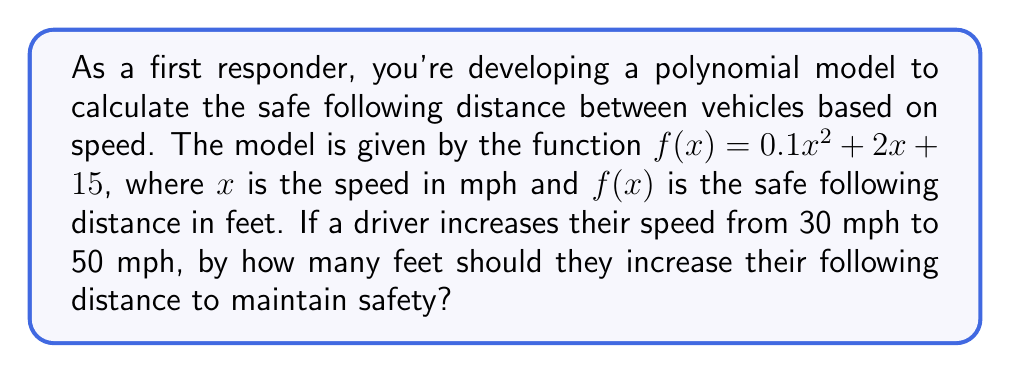Provide a solution to this math problem. To solve this problem, we need to follow these steps:

1) Calculate the safe following distance at 30 mph:
   $f(30) = 0.1(30)^2 + 2(30) + 15$
   $= 0.1(900) + 60 + 15$
   $= 90 + 60 + 15$
   $= 165$ feet

2) Calculate the safe following distance at 50 mph:
   $f(50) = 0.1(50)^2 + 2(50) + 15$
   $= 0.1(2500) + 100 + 15$
   $= 250 + 100 + 15$
   $= 365$ feet

3) Calculate the difference between these two distances:
   $365 - 165 = 200$ feet

Therefore, the driver should increase their following distance by 200 feet when increasing speed from 30 mph to 50 mph.
Answer: 200 feet 